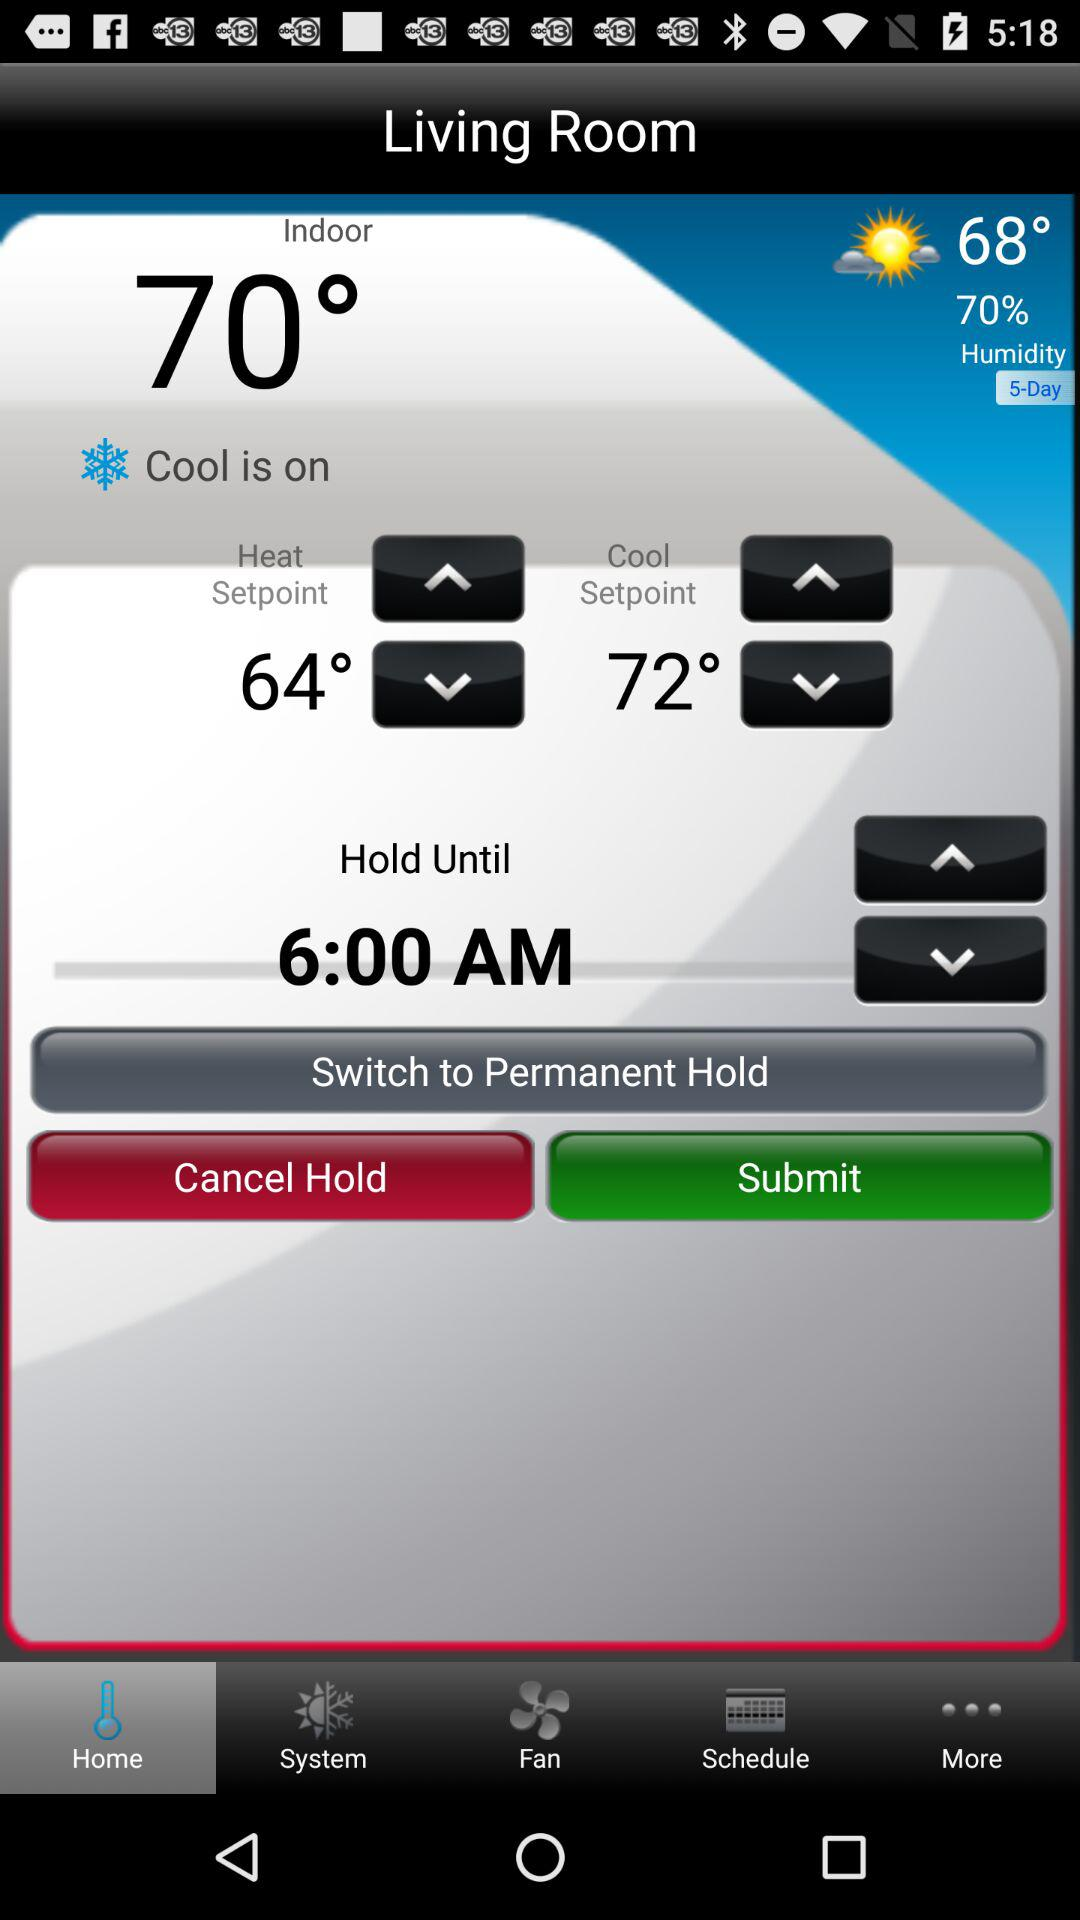How much humidity is there in the air? The humidity in the air is 70%. 